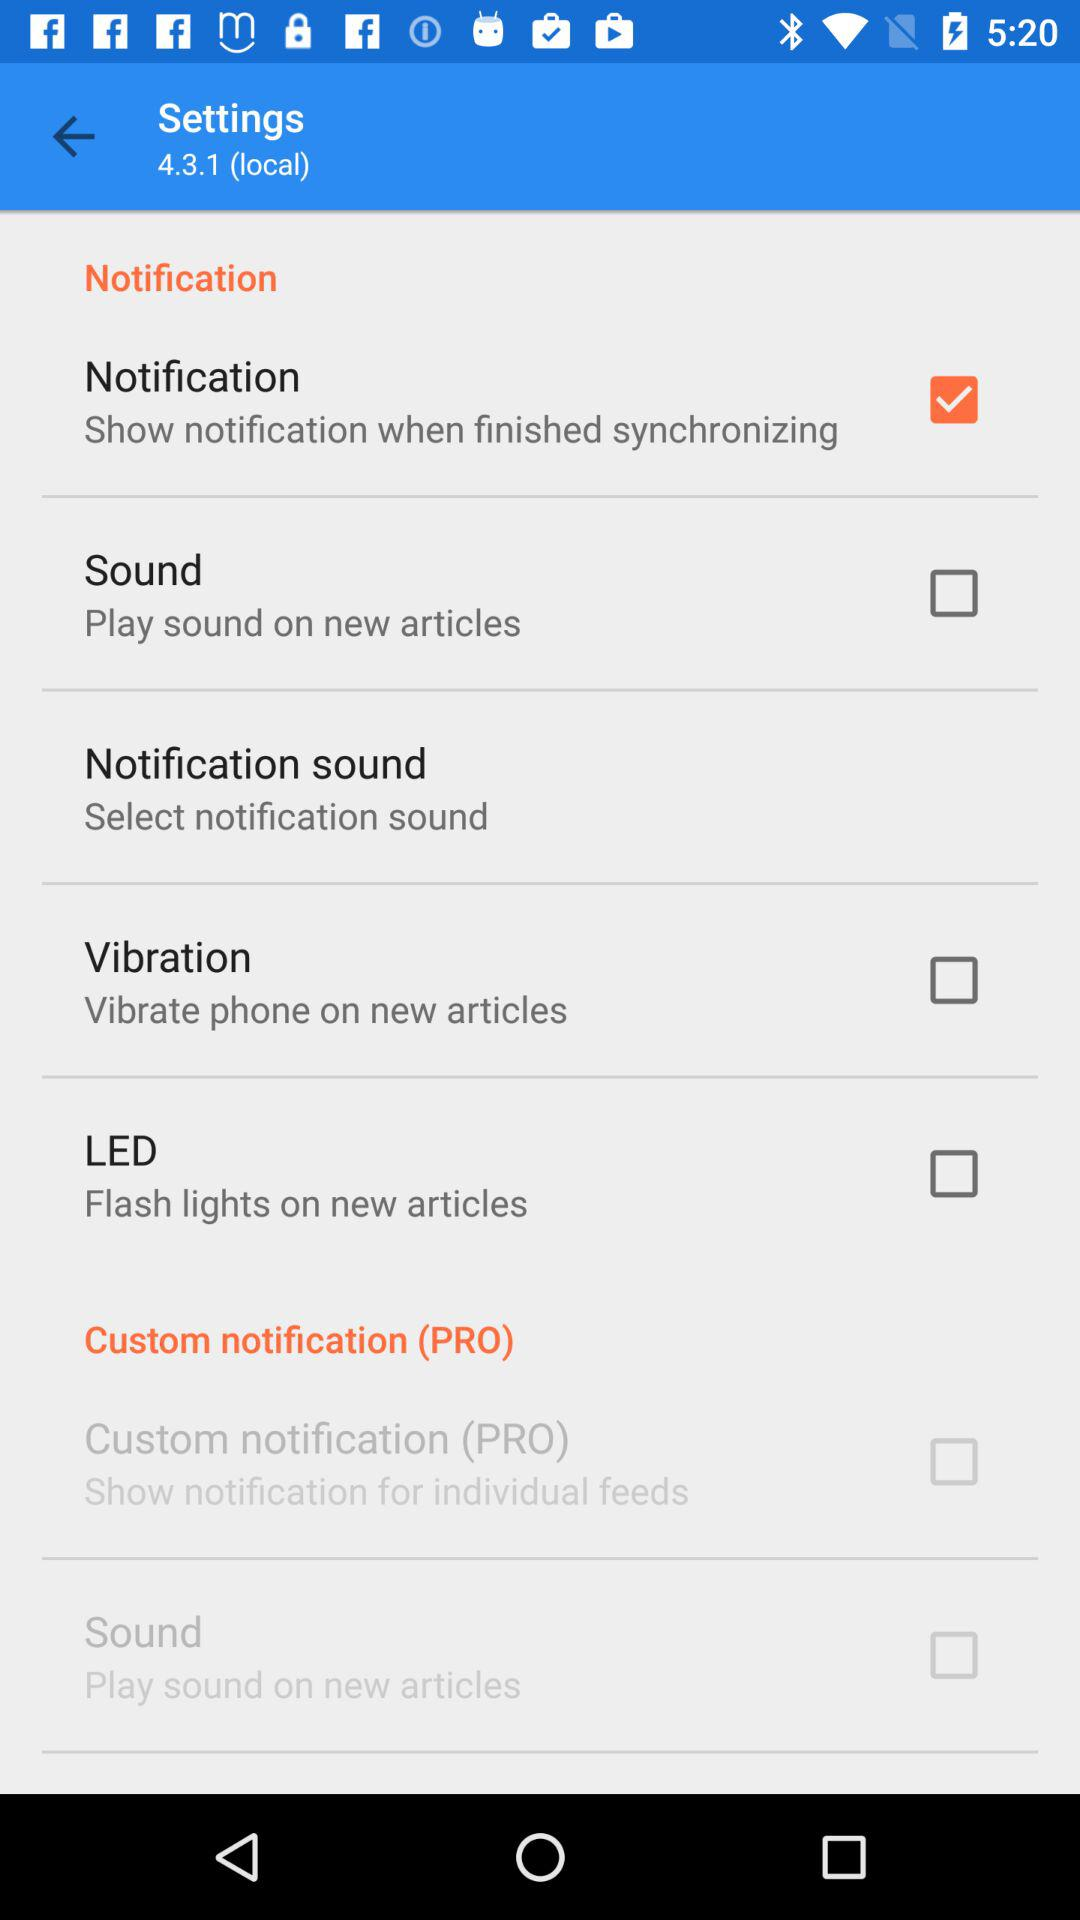What is the version number? The version number is 4.3.1 (local). 